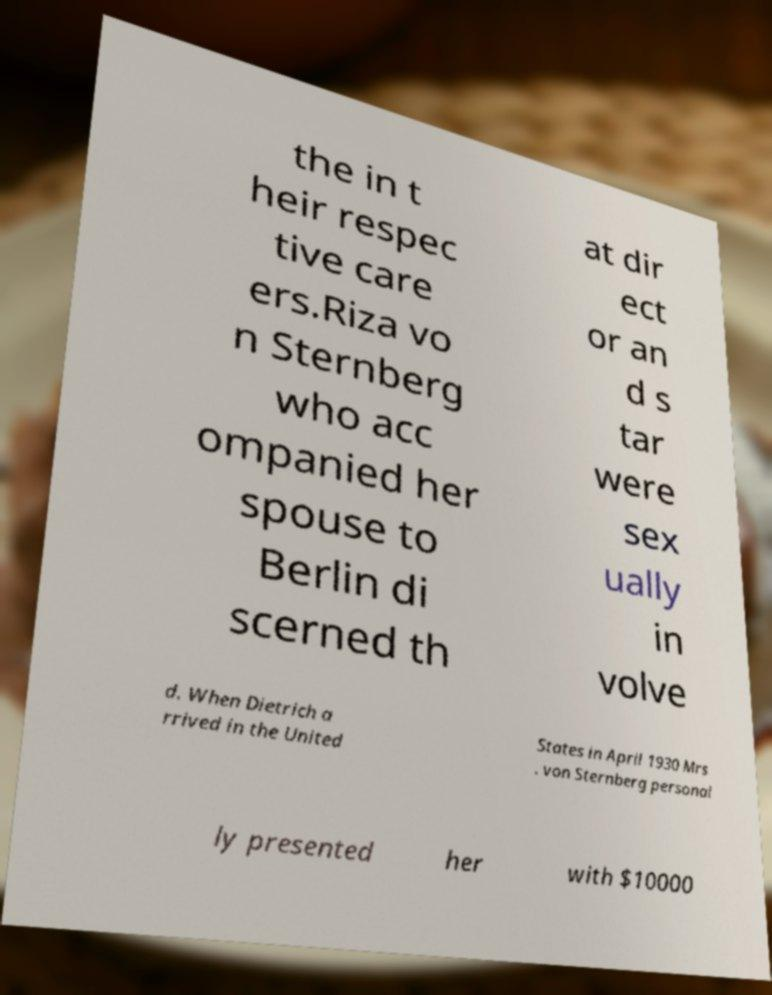Can you accurately transcribe the text from the provided image for me? the in t heir respec tive care ers.Riza vo n Sternberg who acc ompanied her spouse to Berlin di scerned th at dir ect or an d s tar were sex ually in volve d. When Dietrich a rrived in the United States in April 1930 Mrs . von Sternberg personal ly presented her with $10000 